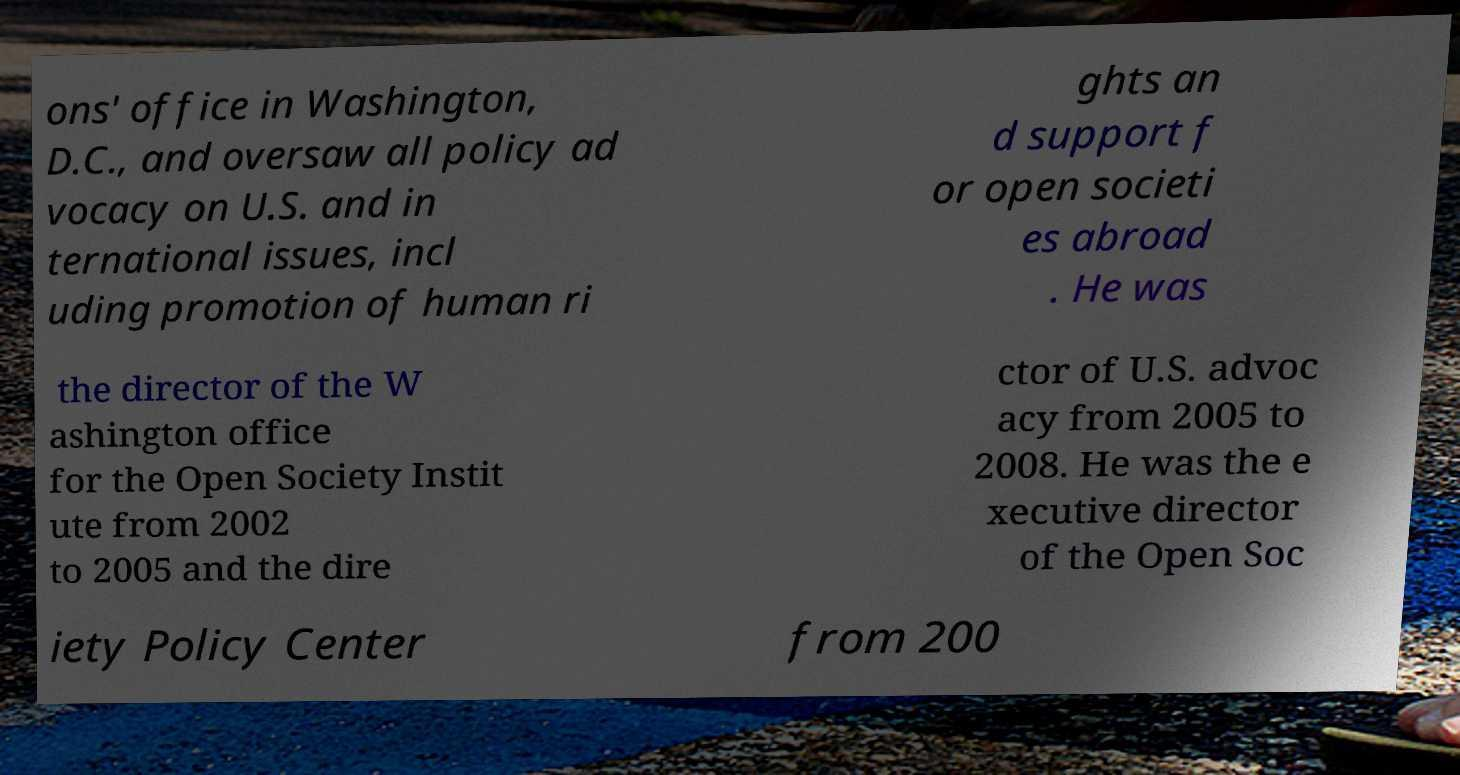Could you extract and type out the text from this image? ons' office in Washington, D.C., and oversaw all policy ad vocacy on U.S. and in ternational issues, incl uding promotion of human ri ghts an d support f or open societi es abroad . He was the director of the W ashington office for the Open Society Instit ute from 2002 to 2005 and the dire ctor of U.S. advoc acy from 2005 to 2008. He was the e xecutive director of the Open Soc iety Policy Center from 200 